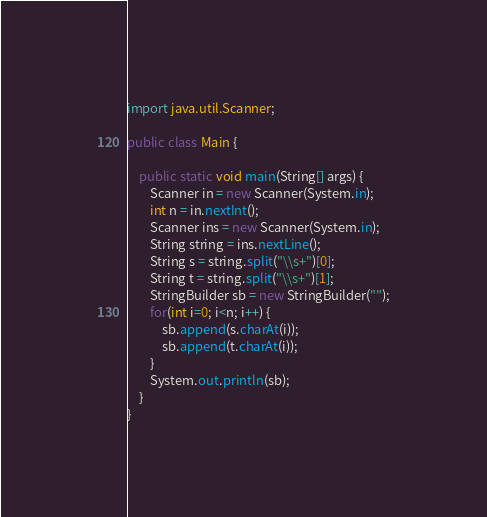Convert code to text. <code><loc_0><loc_0><loc_500><loc_500><_Java_>import java.util.Scanner;

public class Main {
	
	public static void main(String[] args) {
		Scanner in = new Scanner(System.in);
		int n = in.nextInt();
		Scanner ins = new Scanner(System.in);
		String string = ins.nextLine();
		String s = string.split("\\s+")[0];
		String t = string.split("\\s+")[1];
		StringBuilder sb = new StringBuilder("");
		for(int i=0; i<n; i++) {
			sb.append(s.charAt(i));
			sb.append(t.charAt(i));
		}
		System.out.println(sb);
	}
}</code> 